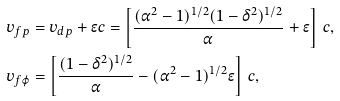<formula> <loc_0><loc_0><loc_500><loc_500>v _ { f p } & = v _ { d p } + \epsilon c = \left [ \frac { ( \alpha ^ { 2 } - 1 ) ^ { 1 / 2 } ( 1 - \delta ^ { 2 } ) ^ { 1 / 2 } } { \alpha } + \epsilon \right ] \, c , \\ v _ { f \varphi } & = \left [ \frac { ( 1 - \delta ^ { 2 } ) ^ { 1 / 2 } } { \alpha } - ( \alpha ^ { 2 } - 1 ) ^ { 1 / 2 } \epsilon \right ] \, c ,</formula> 